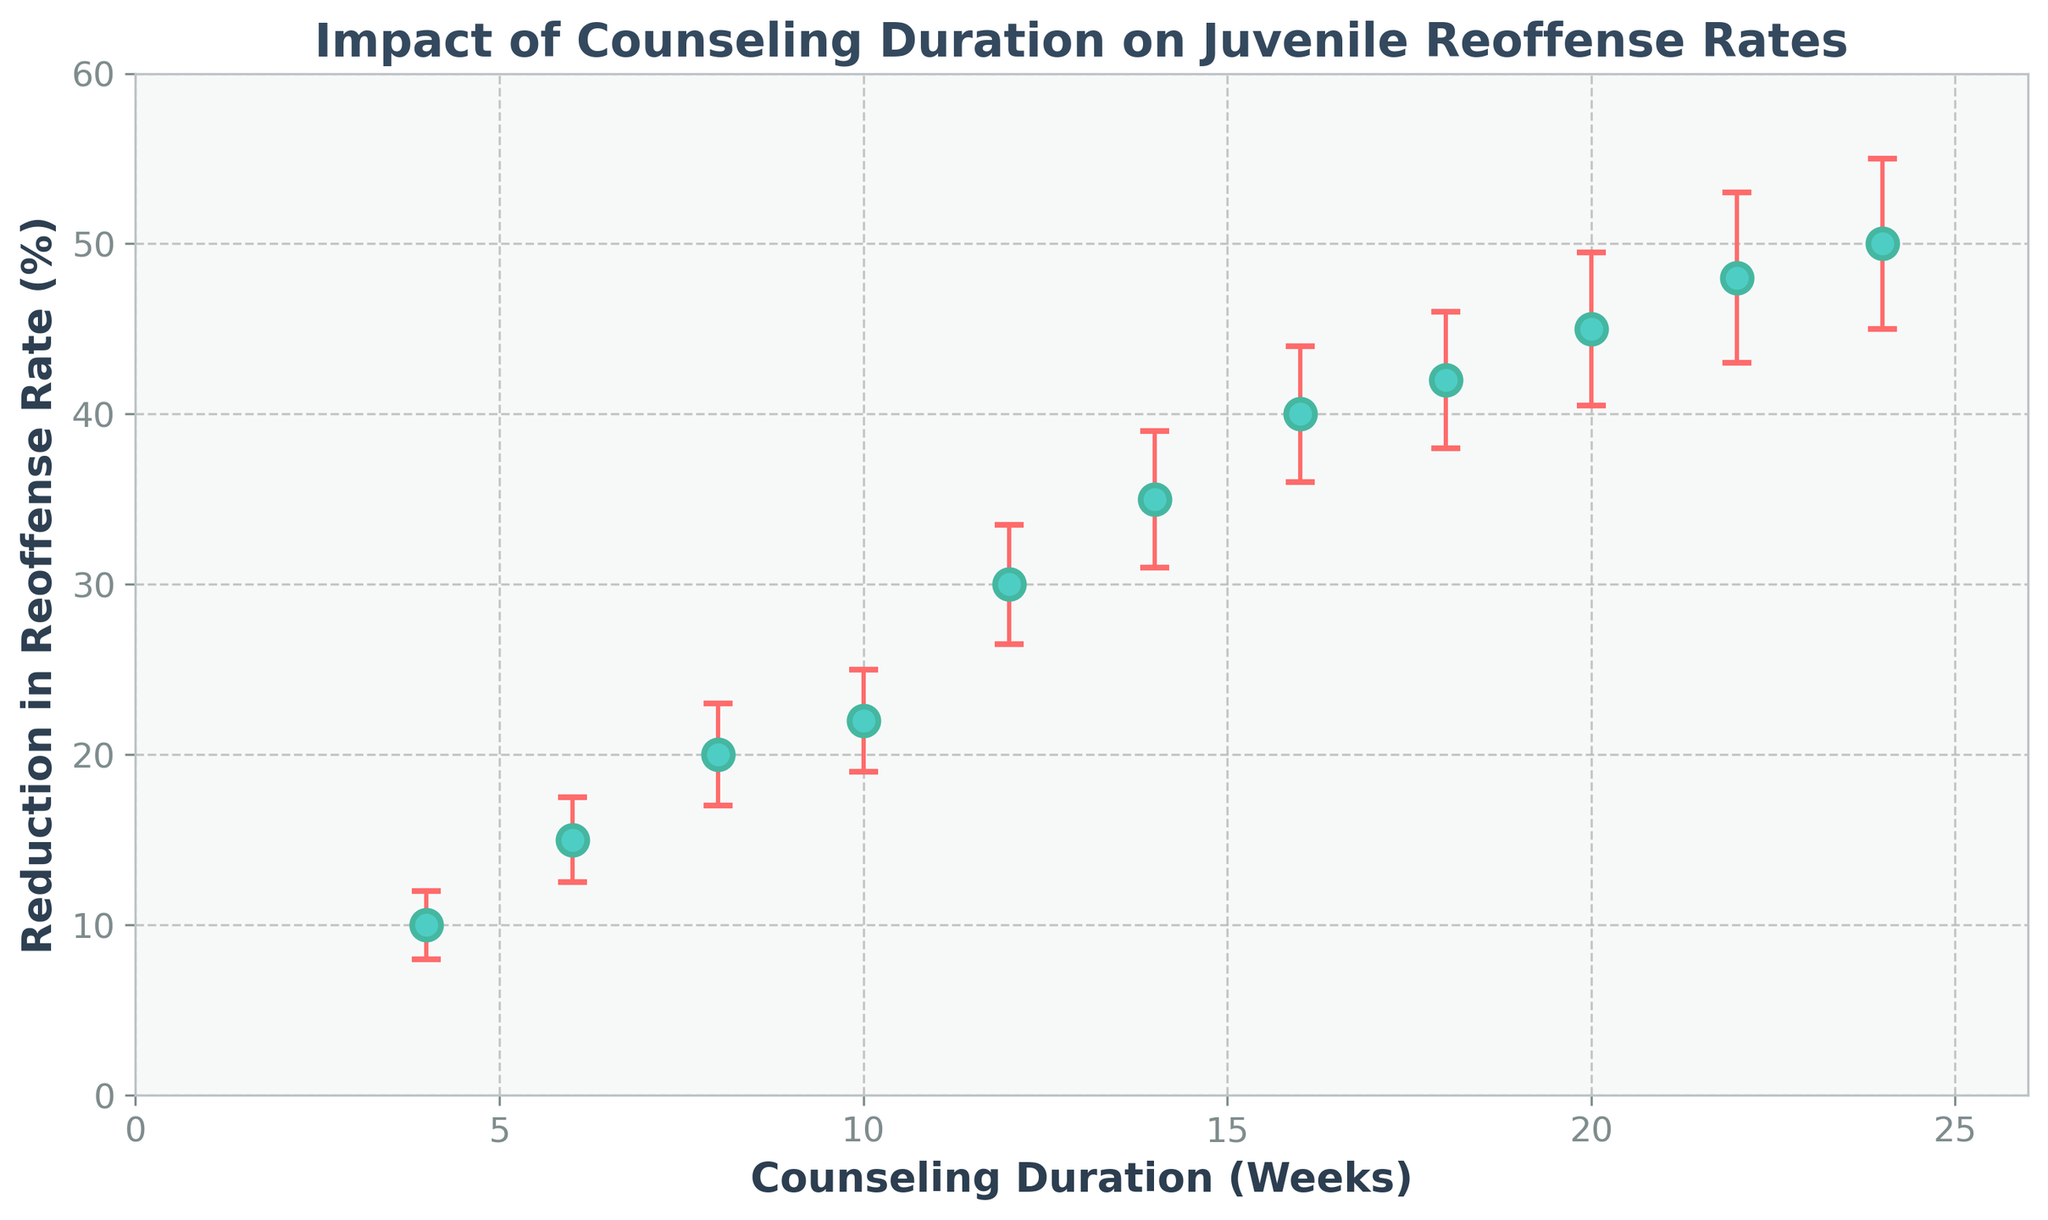What's the title of the figure? The title is printed at the top center of the figure and provides an overview of the content. In this case, the title is clear and descriptive about the data being represented.
Answer: Impact of Counseling Duration on Juvenile Reoffense Rates What are the labels for the x-axis and y-axis? The labels next to the axes indicate what the axes represent. They help to understand what each axis measures. The x-axis label describes the counseling duration in weeks, while the y-axis label shows the reduction in reoffense rate as a percentage.
Answer: Counseling Duration (Weeks), Reduction in Reoffense Rate (%) How many data points are plotted in the figure? Each data point in the scatter plot corresponds to a specific counseling duration and its associated reduction in reoffense rate. You can determine the count by looking at the individual markers.
Answer: 11 What is the reoffense rate reduction for a counseling duration of 16 weeks? First, identify the data point corresponding to 16 weeks on the x-axis. Then, trace vertically to find its value on the y-axis. This shows the reduction percentage.
Answer: 40% What is the difference in reoffense rate reduction between 8 weeks and 18 weeks of counseling? Find the reoffense reduction rate for 8 weeks and 18 weeks by tracing vertically from these points on the x-axis to their respective y-axis values. Then, subtract the 8-week value from the 18-week value.
Answer: 22% Which counseling duration has the highest reduction in reoffense rate? Look for the data point with the greatest y-axis value and match it to the corresponding x-axis value. This gives the duration with the highest reoffense reduction rate.
Answer: 24 weeks How does the error bar size change with counseling duration? Assess the vertical error bars across different data points to see if they increase, decrease, or remain constant with changes in counseling duration.
Answer: Increases What is the average reduction in reoffense rate for counseling durations of 6, 12, and 20 weeks? Find the y-values for 6, 12, and 20 weeks, add these values together, and divide by the number of points (3) to get the average.
Answer: (15 + 30 + 45) / 3 = 30% Is there an increasing trend in the reduction of reoffense rate with increased counseling duration? Observe the general direction of the data points from left to right. An increasing trend would show points moving higher on the y-axis as x-axis values increase.
Answer: Yes What is the range of error bars for the counseling duration of 22 weeks? For 22 weeks, note the size of the error bar that extends above and below the data point on the y-axis. The range will be the difference between the upper and lower bounds of the error bar from the data point.
Answer: ±5% 